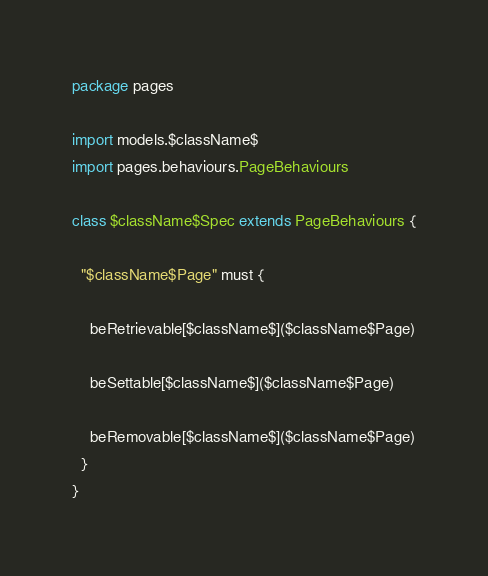Convert code to text. <code><loc_0><loc_0><loc_500><loc_500><_Scala_>package pages

import models.$className$
import pages.behaviours.PageBehaviours

class $className$Spec extends PageBehaviours {

  "$className$Page" must {

    beRetrievable[$className$]($className$Page)

    beSettable[$className$]($className$Page)

    beRemovable[$className$]($className$Page)
  }
}
</code> 